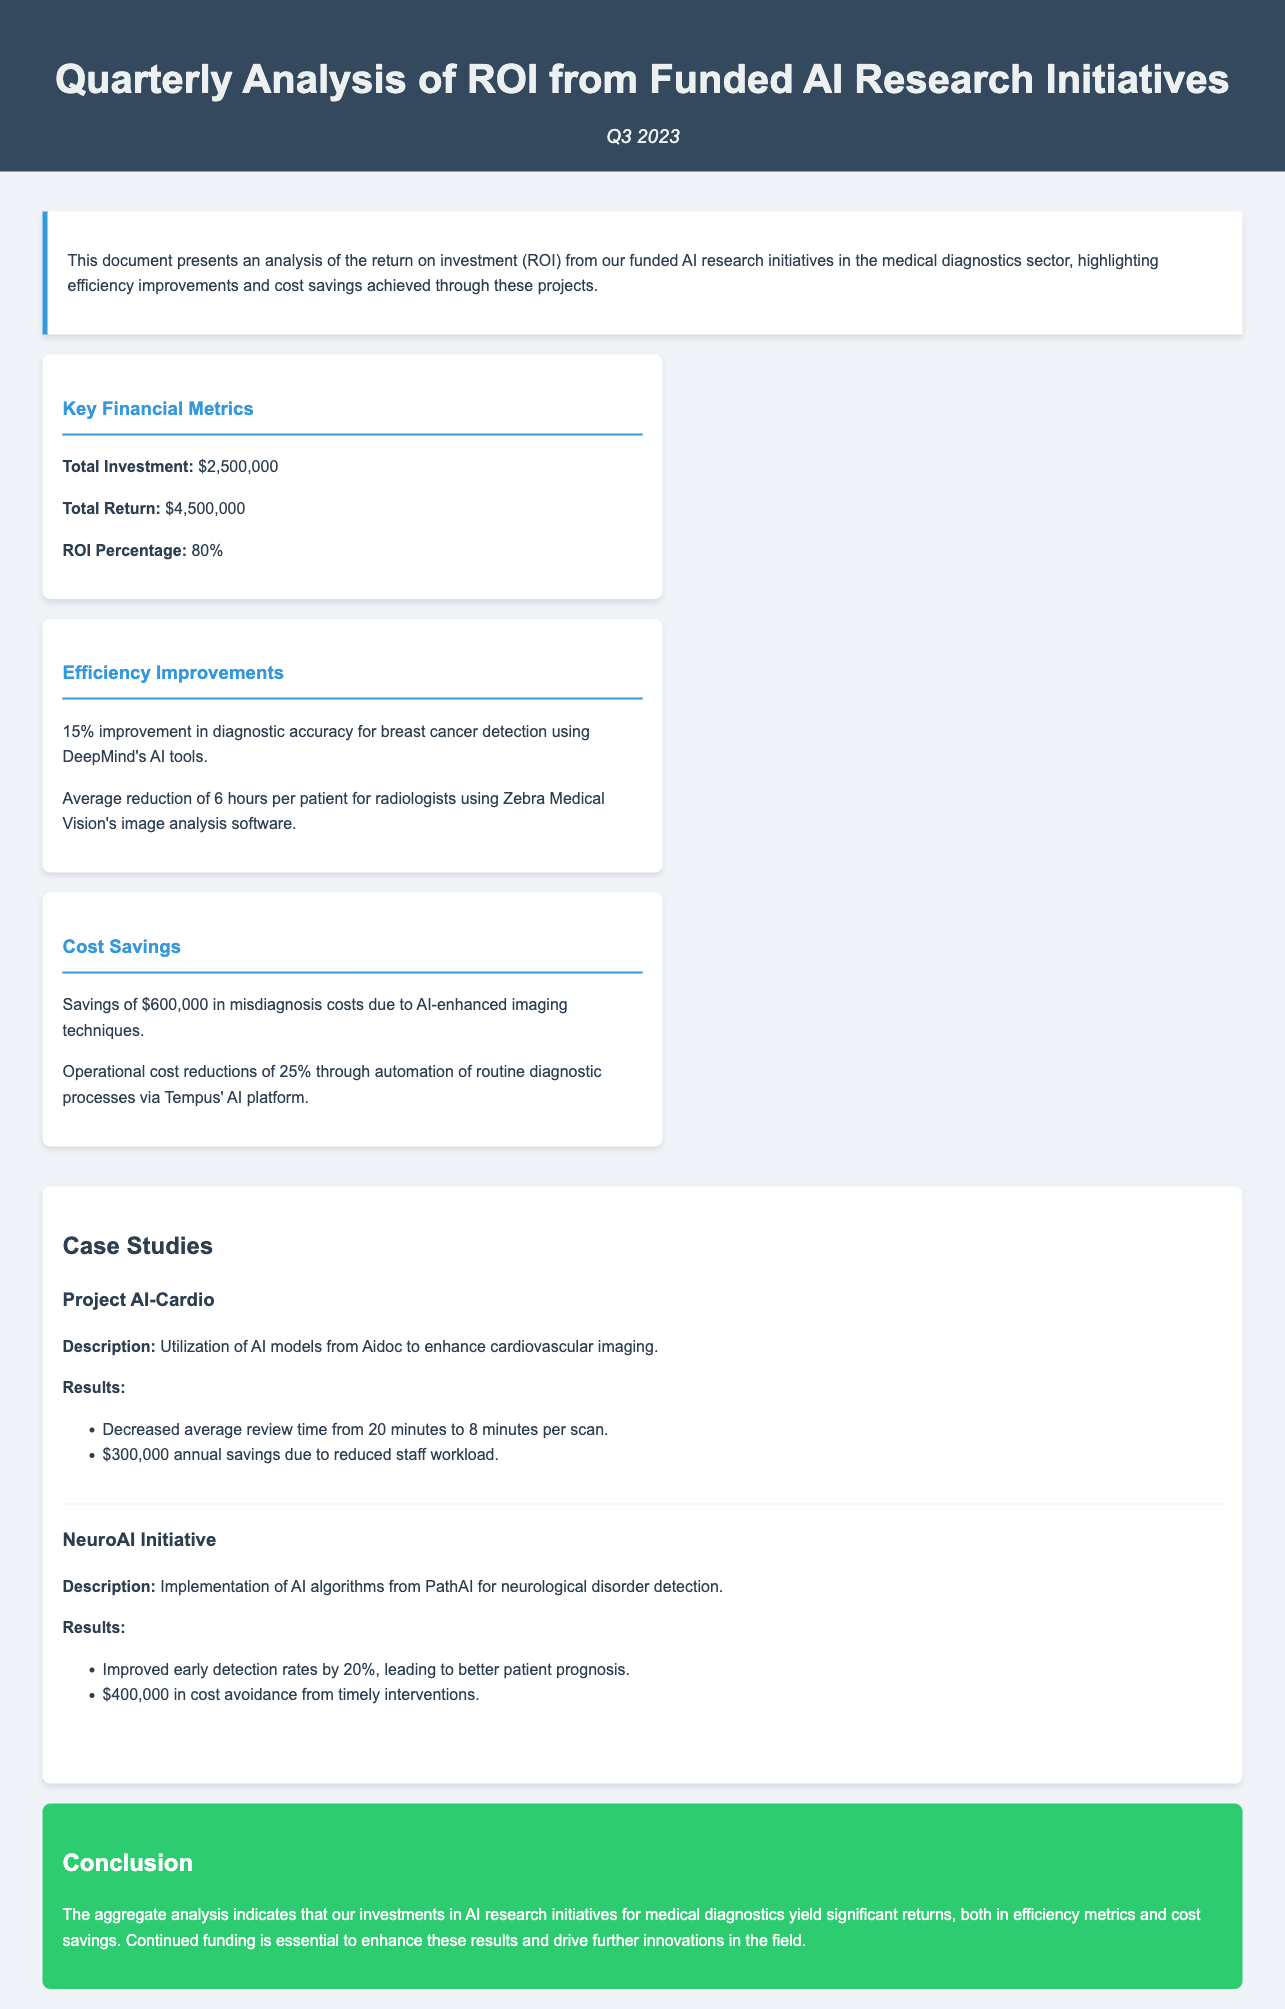What is the total investment? The total investment is explicitly stated in the document as $2,500,000.
Answer: $2,500,000 What is the ROI percentage? The ROI percentage is given in the financial metrics section, calculated as a percentage of returns over investments.
Answer: 80% What is the savings from misdiagnosis costs? The document states that the savings from misdiagnosis costs due to AI-enhanced imaging techniques is $600,000.
Answer: $600,000 How much time was reduced in average review time for Project AI-Cardio? The project details indicate the average review time was reduced from 20 minutes to 8 minutes per scan, demonstrating a reduction of 12 minutes.
Answer: 12 minutes What percentage improvement was achieved in diagnostic accuracy for breast cancer detection? The efficiency improvements section specifies a 15% improvement in diagnostic accuracy using DeepMind's AI tools.
Answer: 15% What total return is reported for the AI research initiatives? The total return from the funded AI research initiatives is reported as $4,500,000.
Answer: $4,500,000 What operational cost reduction percentage was achieved through automation? The document mentions an operational cost reduction of 25% through automation of routine diagnostic processes.
Answer: 25% Which project resulted in $400,000 in cost avoidance? The case study for the NeuroAI Initiative notes that it led to $400,000 in cost avoidance from timely interventions.
Answer: NeuroAI Initiative 